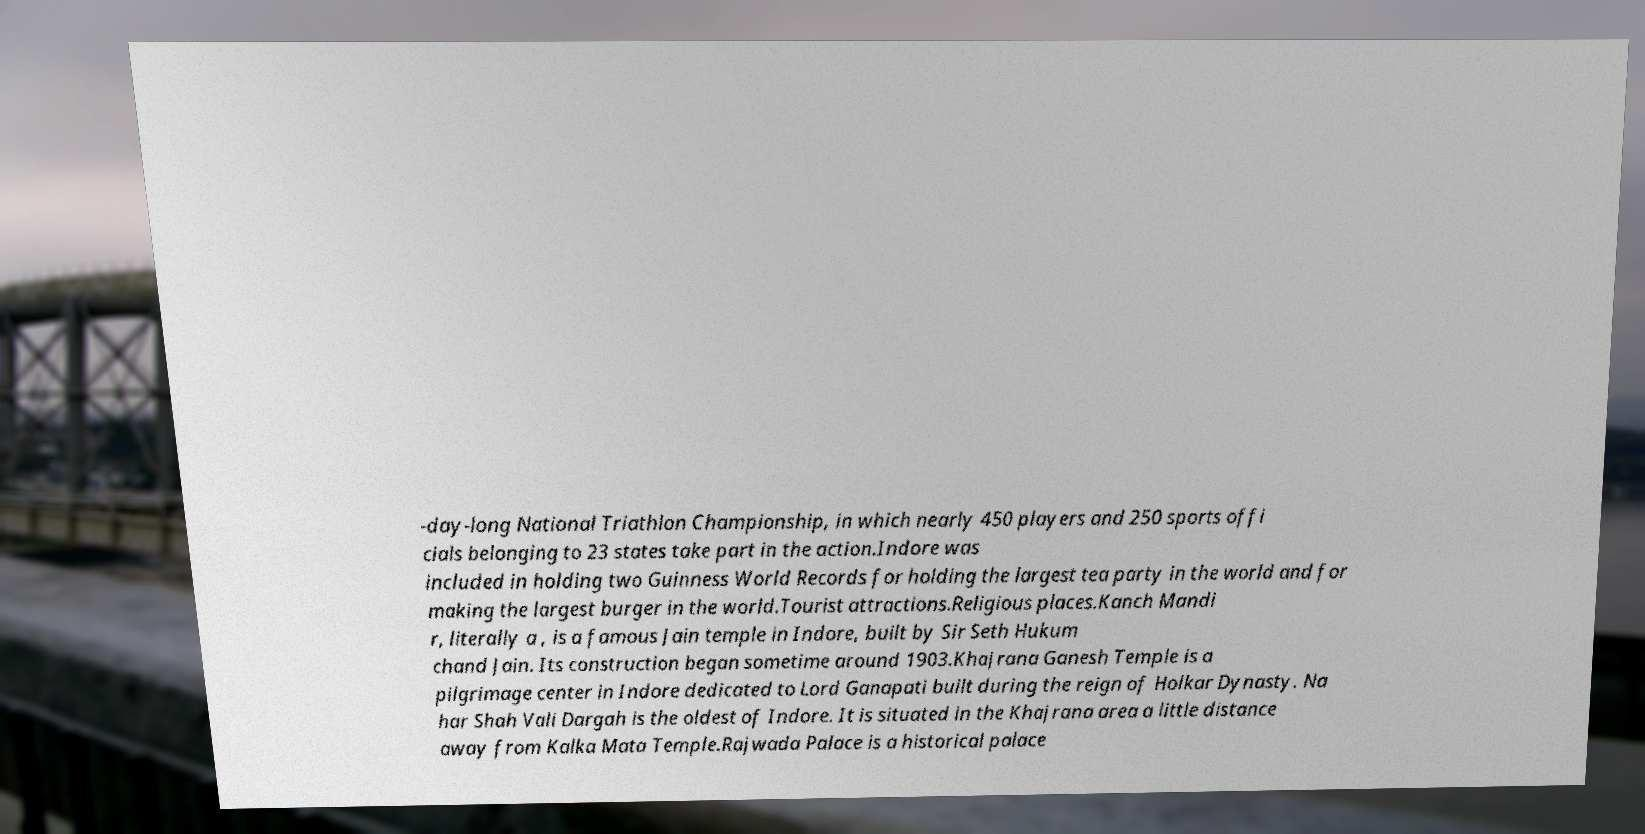Please identify and transcribe the text found in this image. -day-long National Triathlon Championship, in which nearly 450 players and 250 sports offi cials belonging to 23 states take part in the action.Indore was included in holding two Guinness World Records for holding the largest tea party in the world and for making the largest burger in the world.Tourist attractions.Religious places.Kanch Mandi r, literally a , is a famous Jain temple in Indore, built by Sir Seth Hukum chand Jain. Its construction began sometime around 1903.Khajrana Ganesh Temple is a pilgrimage center in Indore dedicated to Lord Ganapati built during the reign of Holkar Dynasty. Na har Shah Vali Dargah is the oldest of Indore. It is situated in the Khajrana area a little distance away from Kalka Mata Temple.Rajwada Palace is a historical palace 